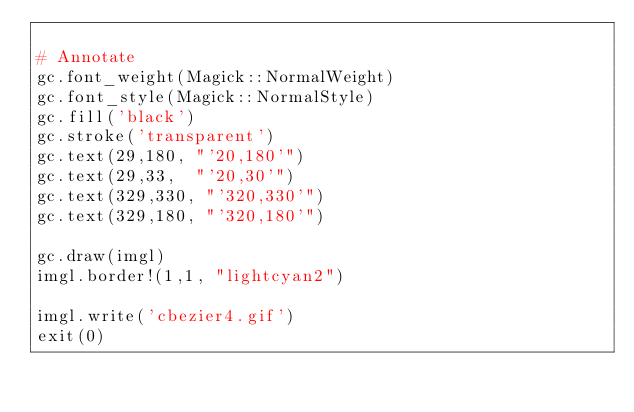<code> <loc_0><loc_0><loc_500><loc_500><_Ruby_>
# Annotate
gc.font_weight(Magick::NormalWeight)
gc.font_style(Magick::NormalStyle)
gc.fill('black')
gc.stroke('transparent')
gc.text(29,180, "'20,180'")
gc.text(29,33,  "'20,30'")
gc.text(329,330, "'320,330'")
gc.text(329,180, "'320,180'")

gc.draw(imgl)
imgl.border!(1,1, "lightcyan2")

imgl.write('cbezier4.gif')
exit(0)

</code> 